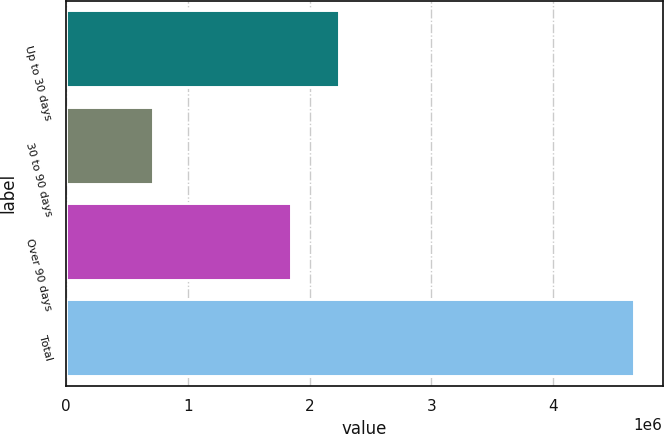Convert chart. <chart><loc_0><loc_0><loc_500><loc_500><bar_chart><fcel>Up to 30 days<fcel>30 to 90 days<fcel>Over 90 days<fcel>Total<nl><fcel>2.24335e+06<fcel>712991<fcel>1.84805e+06<fcel>4.66598e+06<nl></chart> 